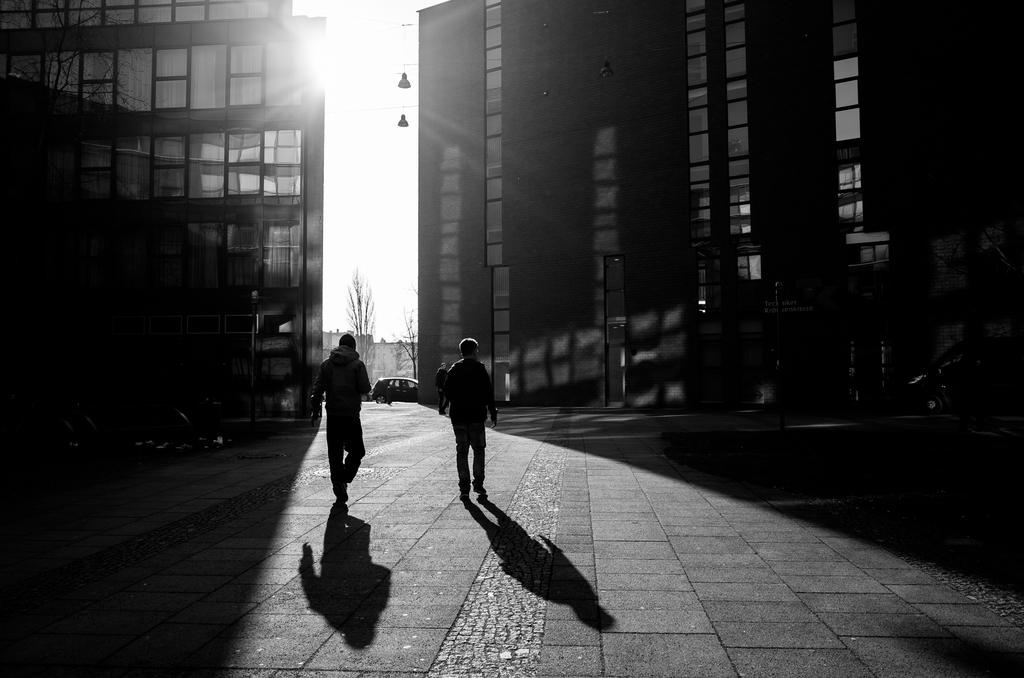What are the two persons in the foreground of the image doing? The two persons in the foreground of the image are walking. On what surface are the persons walking? The persons are walking on the ground. What can be seen in the background of the image? There are buildings, trees, and the sky visible in the background of the image. What type of plant is the sun watering in the image? There is no plant or sun present in the image; it features two persons walking in the foreground and buildings, trees, and the sky in the background. 